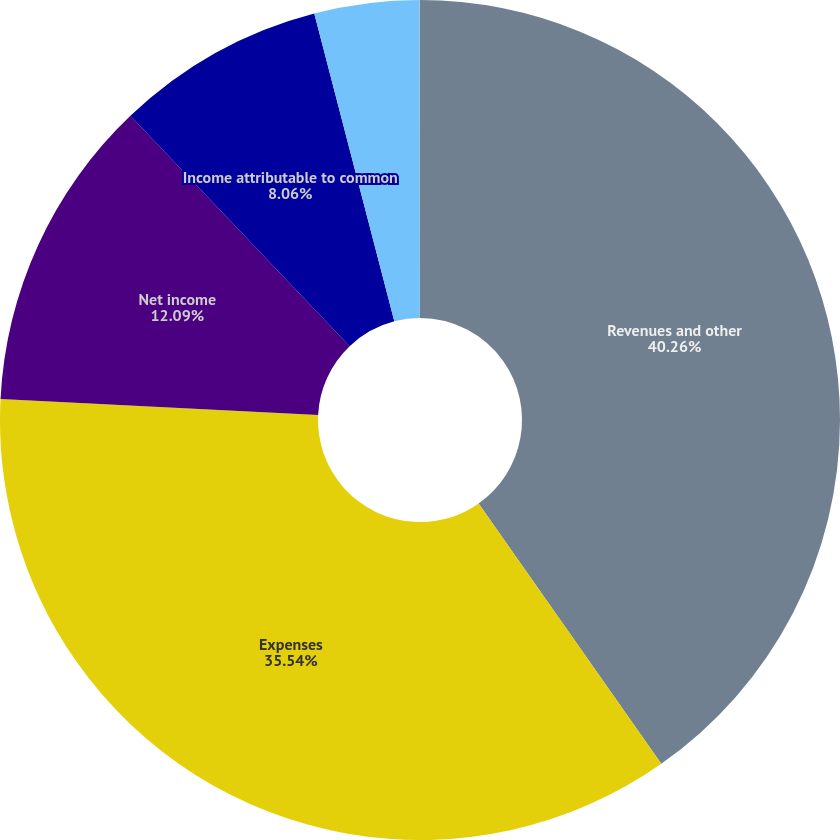Convert chart. <chart><loc_0><loc_0><loc_500><loc_500><pie_chart><fcel>Revenues and other<fcel>Expenses<fcel>Net income<fcel>Income attributable to common<fcel>Basic<fcel>Diluted<nl><fcel>40.26%<fcel>35.54%<fcel>12.09%<fcel>8.06%<fcel>4.04%<fcel>0.01%<nl></chart> 